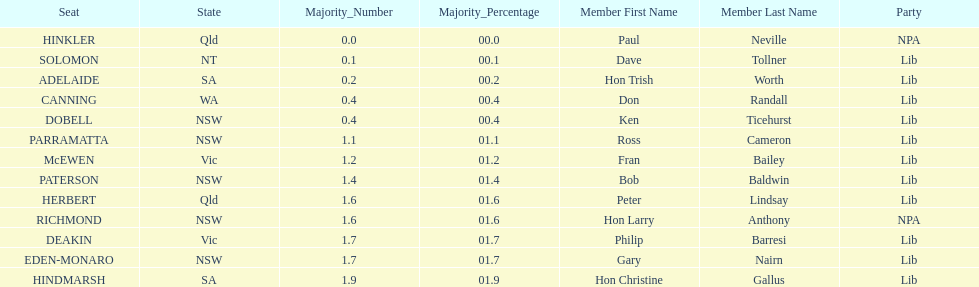Tell me the number of seats from nsw? 5. 